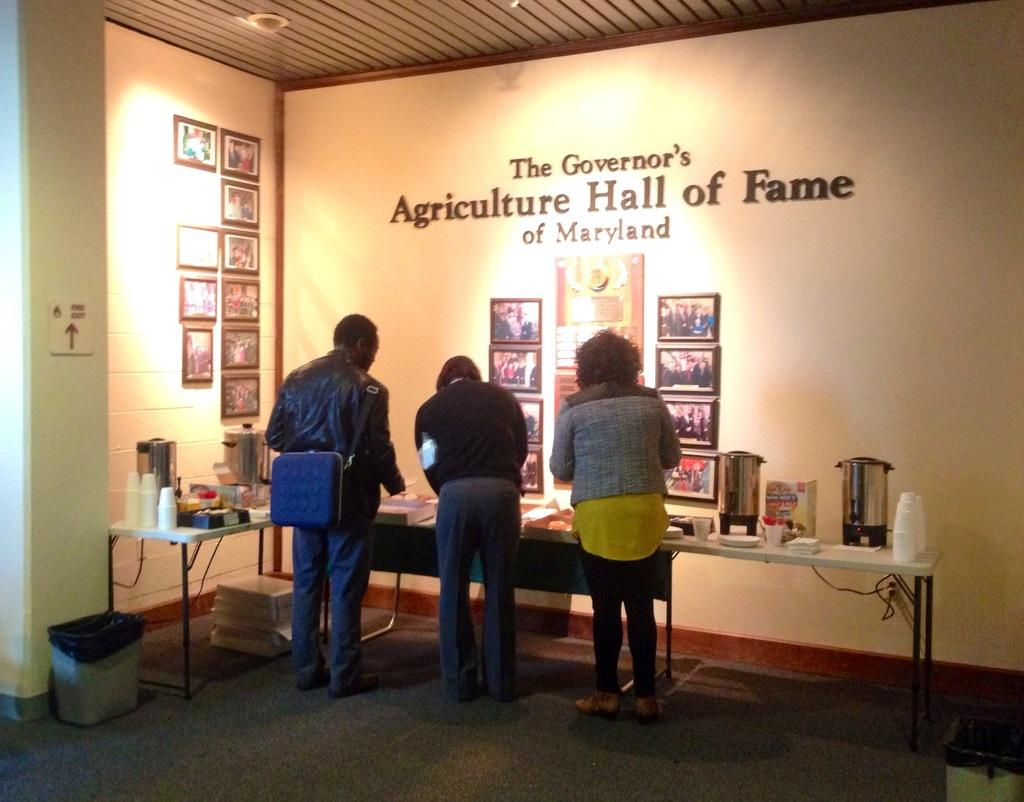Provide a one-sentence caption for the provided image. People gather around a refreshments table at the Agriculture Hall of Fame. 